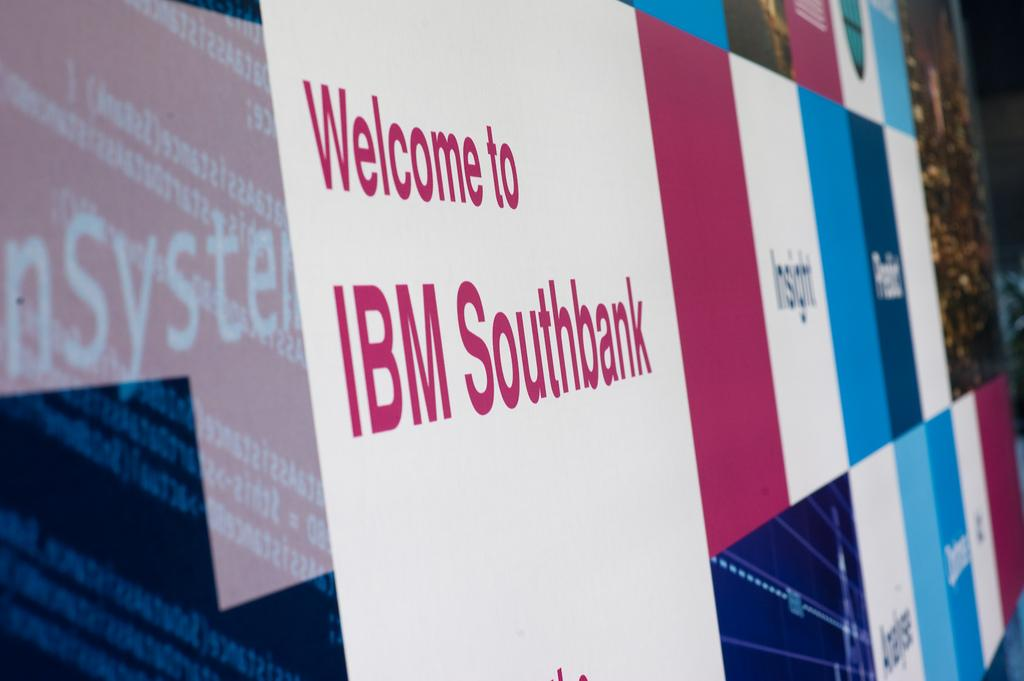<image>
Summarize the visual content of the image. A large billboard has a welcome sign from IBM south bank. 